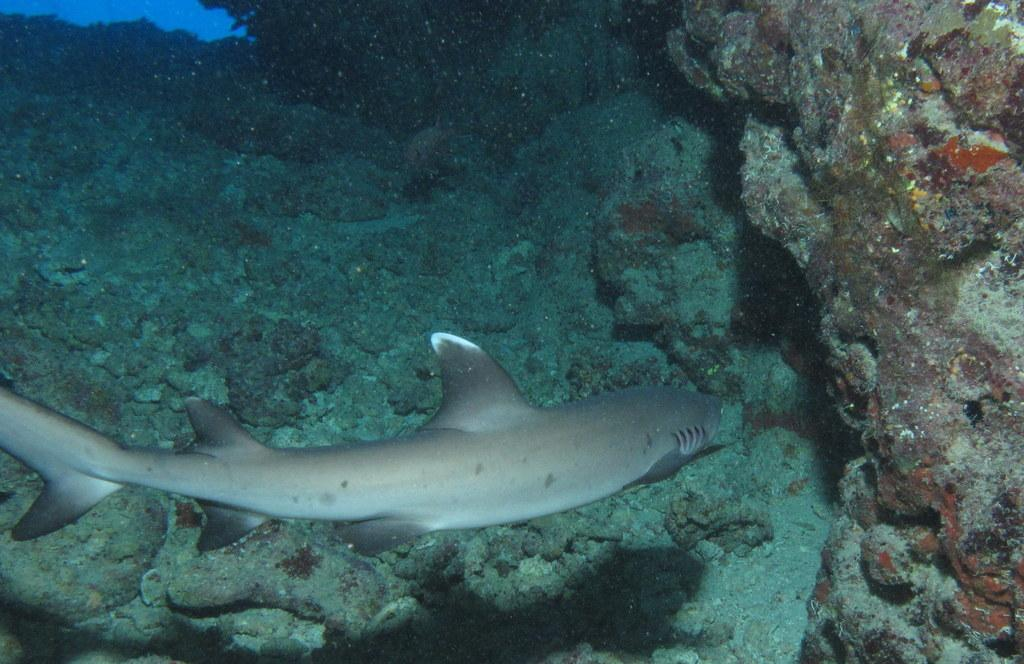What type of animals can be seen in the water in the image? There are fish in the water in the image. What other objects can be seen in the image besides the fish? There are rocks in the image. What type of protest is taking place in the image? There is no protest present in the image; it features fish in the water and rocks. Can you tell me how many lawyers are visible in the image? There are no lawyers present in the image. 